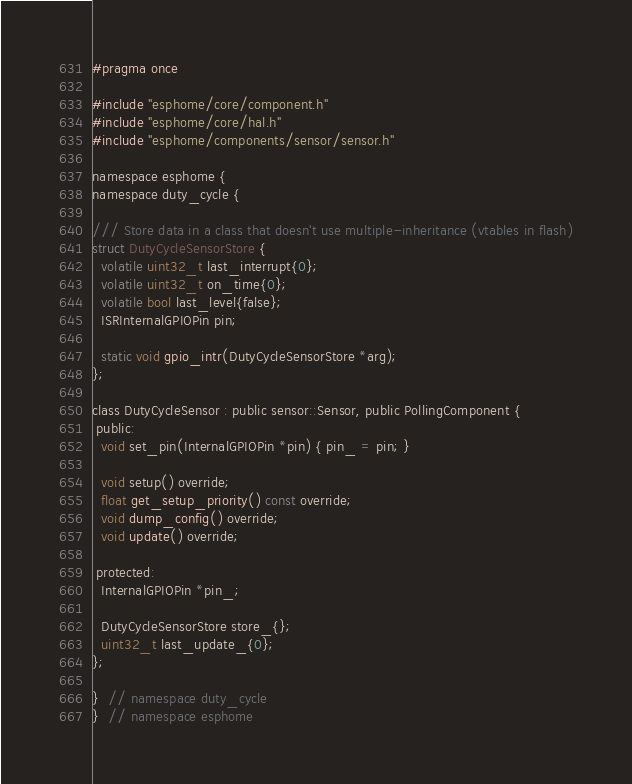<code> <loc_0><loc_0><loc_500><loc_500><_C_>#pragma once

#include "esphome/core/component.h"
#include "esphome/core/hal.h"
#include "esphome/components/sensor/sensor.h"

namespace esphome {
namespace duty_cycle {

/// Store data in a class that doesn't use multiple-inheritance (vtables in flash)
struct DutyCycleSensorStore {
  volatile uint32_t last_interrupt{0};
  volatile uint32_t on_time{0};
  volatile bool last_level{false};
  ISRInternalGPIOPin pin;

  static void gpio_intr(DutyCycleSensorStore *arg);
};

class DutyCycleSensor : public sensor::Sensor, public PollingComponent {
 public:
  void set_pin(InternalGPIOPin *pin) { pin_ = pin; }

  void setup() override;
  float get_setup_priority() const override;
  void dump_config() override;
  void update() override;

 protected:
  InternalGPIOPin *pin_;

  DutyCycleSensorStore store_{};
  uint32_t last_update_{0};
};

}  // namespace duty_cycle
}  // namespace esphome
</code> 